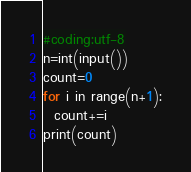<code> <loc_0><loc_0><loc_500><loc_500><_Python_>#coding:utf-8
n=int(input())
count=0
for i in range(n+1):
  count+=i
print(count)</code> 